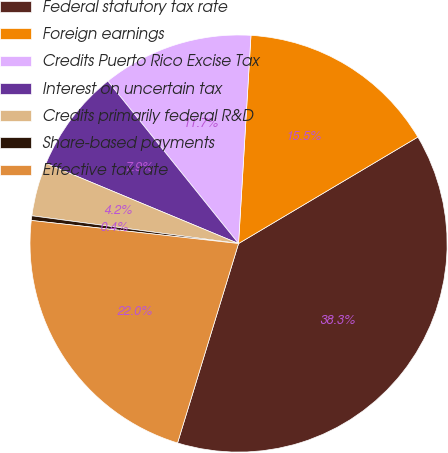Convert chart to OTSL. <chart><loc_0><loc_0><loc_500><loc_500><pie_chart><fcel>Federal statutory tax rate<fcel>Foreign earnings<fcel>Credits Puerto Rico Excise Tax<fcel>Interest on uncertain tax<fcel>Credits primarily federal R&D<fcel>Share-based payments<fcel>Effective tax rate<nl><fcel>38.25%<fcel>15.52%<fcel>11.73%<fcel>7.94%<fcel>4.15%<fcel>0.36%<fcel>22.04%<nl></chart> 